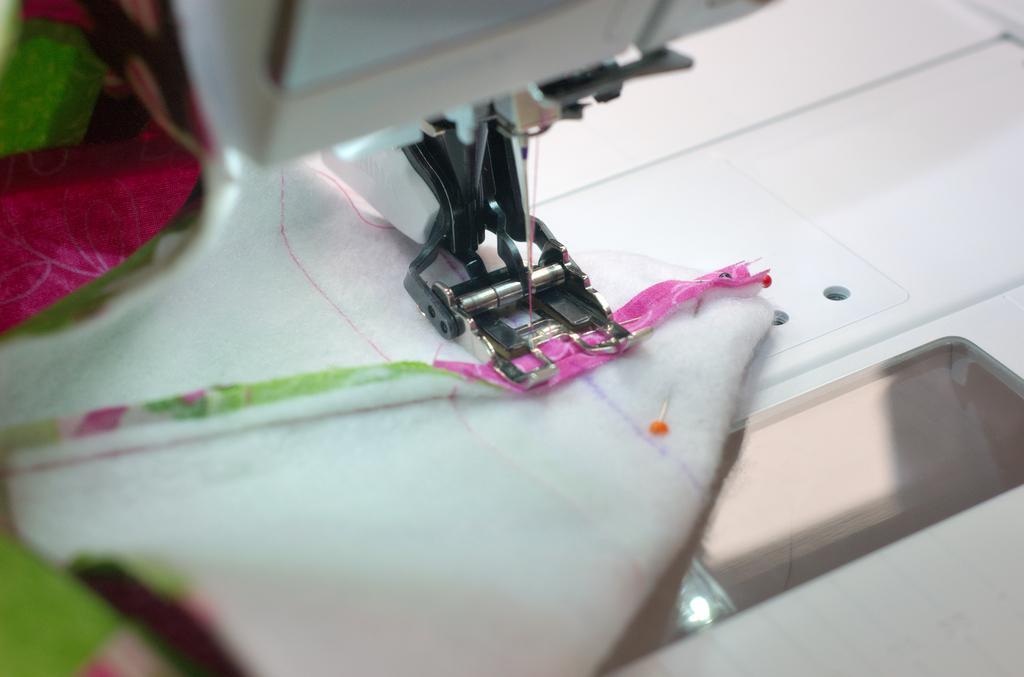Please provide a concise description of this image. In the foreground of this image, there is a sewing machine on which a folded cloth is present on it and a needle to it. 